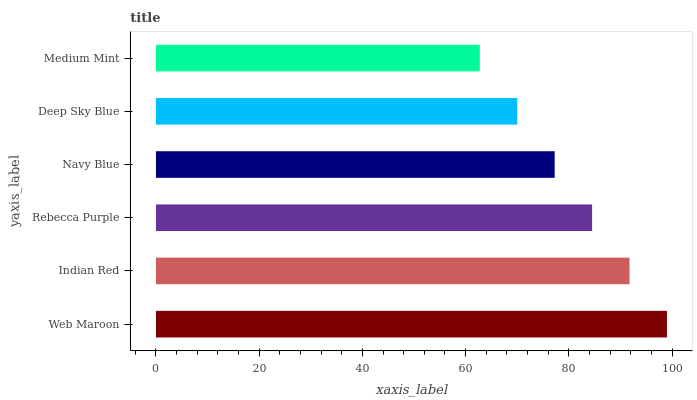Is Medium Mint the minimum?
Answer yes or no. Yes. Is Web Maroon the maximum?
Answer yes or no. Yes. Is Indian Red the minimum?
Answer yes or no. No. Is Indian Red the maximum?
Answer yes or no. No. Is Web Maroon greater than Indian Red?
Answer yes or no. Yes. Is Indian Red less than Web Maroon?
Answer yes or no. Yes. Is Indian Red greater than Web Maroon?
Answer yes or no. No. Is Web Maroon less than Indian Red?
Answer yes or no. No. Is Rebecca Purple the high median?
Answer yes or no. Yes. Is Navy Blue the low median?
Answer yes or no. Yes. Is Indian Red the high median?
Answer yes or no. No. Is Indian Red the low median?
Answer yes or no. No. 